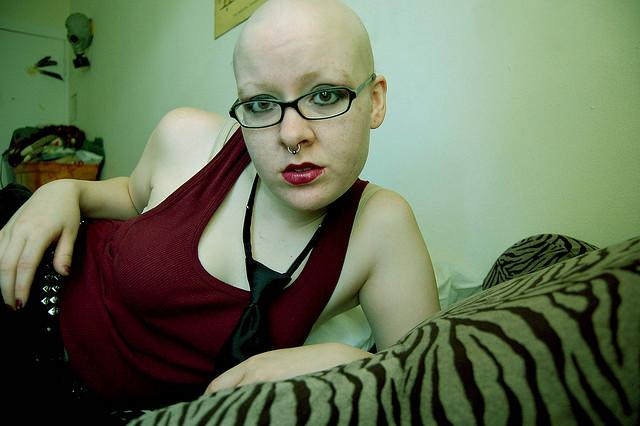What is sh doing? posing 